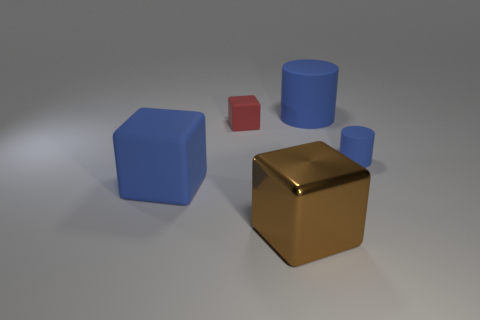Subtract all rubber blocks. How many blocks are left? 1 Add 1 blue matte balls. How many objects exist? 6 Subtract all blocks. How many objects are left? 2 Subtract all purple cubes. Subtract all brown balls. How many cubes are left? 3 Subtract 0 green cubes. How many objects are left? 5 Subtract all big blue rubber cubes. Subtract all red cubes. How many objects are left? 3 Add 4 metallic things. How many metallic things are left? 5 Add 1 large red rubber things. How many large red rubber things exist? 1 